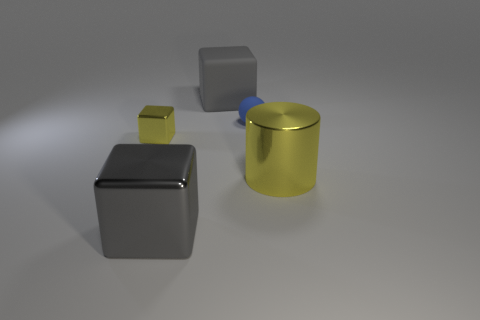There is a large gray thing that is behind the shiny cube that is in front of the small block; what shape is it?
Offer a terse response. Cube. Is there anything else that has the same size as the matte block?
Your response must be concise. Yes. There is a yellow metallic thing that is right of the gray thing that is in front of the yellow shiny object right of the tiny yellow metallic object; what is its shape?
Offer a very short reply. Cylinder. What number of things are either large gray rubber cubes to the left of the sphere or gray cubes that are on the right side of the large metal block?
Keep it short and to the point. 1. There is a yellow metal cylinder; does it have the same size as the yellow metallic object left of the gray shiny block?
Make the answer very short. No. Is the material of the yellow thing that is on the right side of the ball the same as the block that is in front of the large shiny cylinder?
Offer a very short reply. Yes. Are there the same number of blue rubber balls behind the tiny blue sphere and large metal blocks that are behind the yellow cylinder?
Your response must be concise. Yes. How many other matte blocks are the same color as the matte block?
Give a very brief answer. 0. What material is the large thing that is the same color as the small block?
Your response must be concise. Metal. What number of matte things are blue cylinders or small yellow cubes?
Ensure brevity in your answer.  0. 